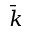Convert formula to latex. <formula><loc_0><loc_0><loc_500><loc_500>\bar { k }</formula> 